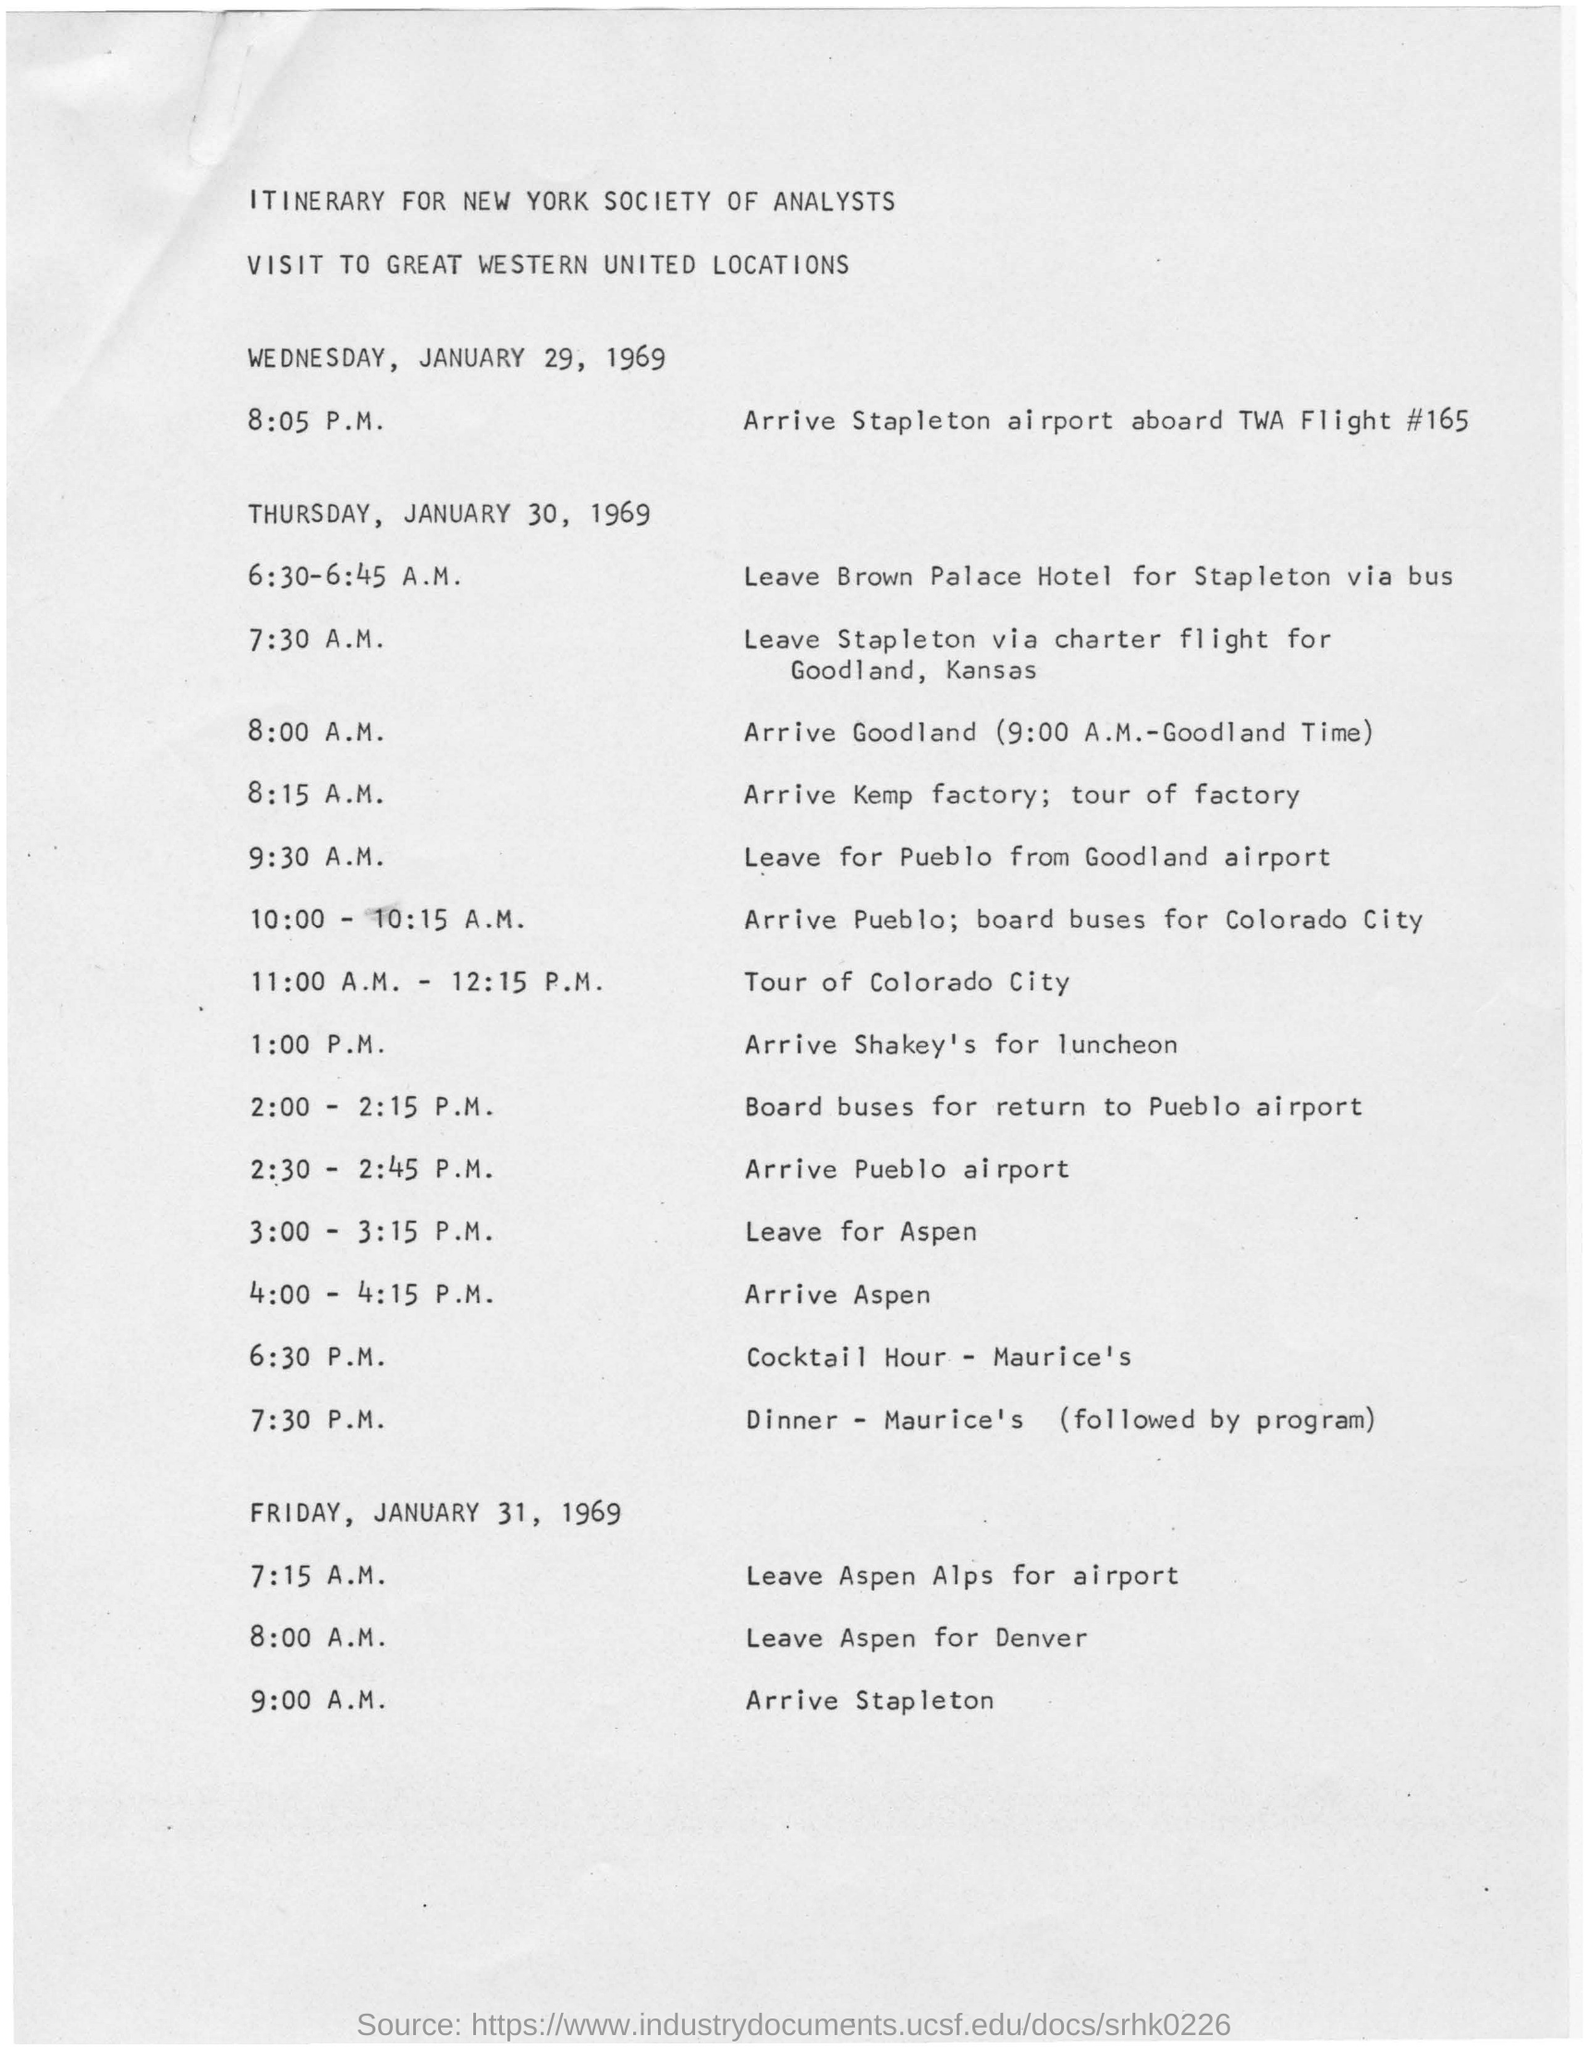Draw attention to some important aspects in this diagram. The itinerary is for a visit to Great Western United Locations. The visit will end on FRIDAY, JANUARY 31, 1969. The visit start date is Wednesday, January 29, 1969. The flight number mentioned for the flight to Stapleton is TWA FLIGHT #165. The itinerary in the document is intended for the New York Society of Analysts. 